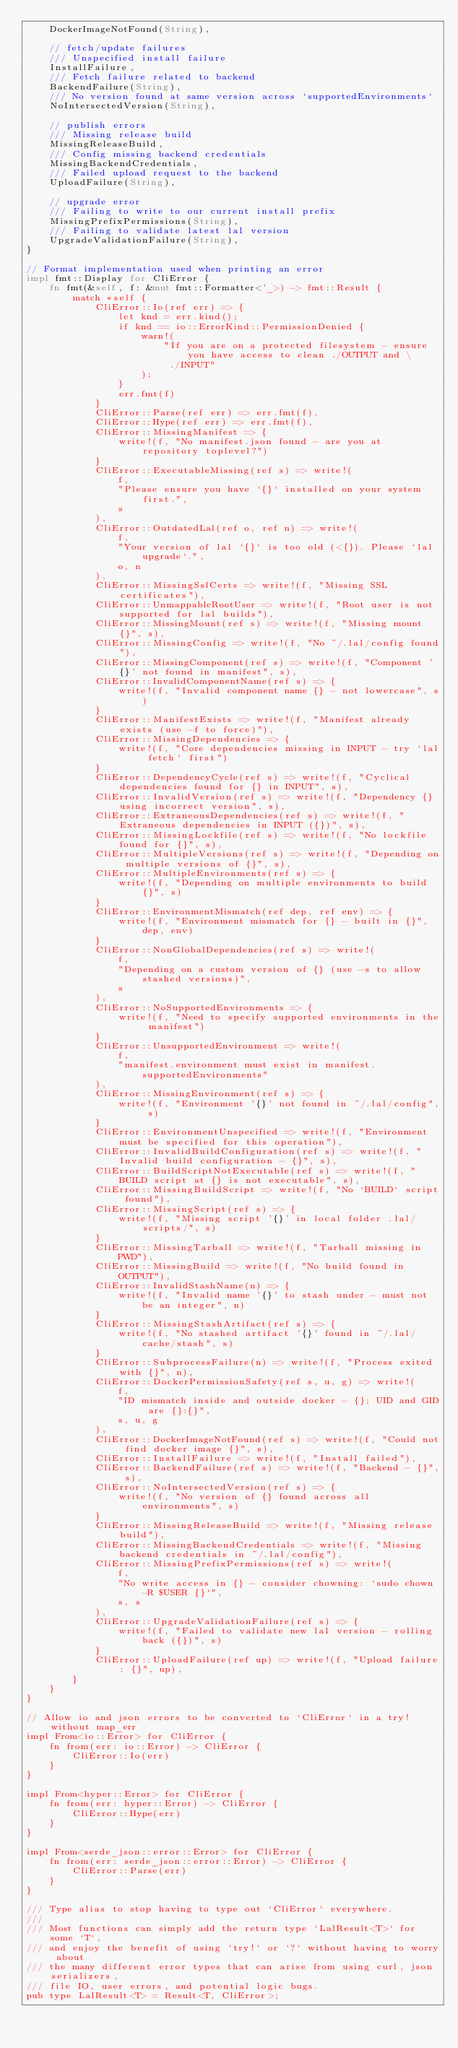Convert code to text. <code><loc_0><loc_0><loc_500><loc_500><_Rust_>    DockerImageNotFound(String),

    // fetch/update failures
    /// Unspecified install failure
    InstallFailure,
    /// Fetch failure related to backend
    BackendFailure(String),
    /// No version found at same version across `supportedEnvironments`
    NoIntersectedVersion(String),

    // publish errors
    /// Missing release build
    MissingReleaseBuild,
    /// Config missing backend credentials
    MissingBackendCredentials,
    /// Failed upload request to the backend
    UploadFailure(String),

    // upgrade error
    /// Failing to write to our current install prefix
    MissingPrefixPermissions(String),
    /// Failing to validate latest lal version
    UpgradeValidationFailure(String),
}

// Format implementation used when printing an error
impl fmt::Display for CliError {
    fn fmt(&self, f: &mut fmt::Formatter<'_>) -> fmt::Result {
        match *self {
            CliError::Io(ref err) => {
                let knd = err.kind();
                if knd == io::ErrorKind::PermissionDenied {
                    warn!(
                        "If you are on a protected filesystem - ensure you have access to clean ./OUTPUT and \
                         ./INPUT"
                    );
                }
                err.fmt(f)
            }
            CliError::Parse(ref err) => err.fmt(f),
            CliError::Hype(ref err) => err.fmt(f),
            CliError::MissingManifest => {
                write!(f, "No manifest.json found - are you at repository toplevel?")
            }
            CliError::ExecutableMissing(ref s) => write!(
                f,
                "Please ensure you have `{}` installed on your system first.",
                s
            ),
            CliError::OutdatedLal(ref o, ref n) => write!(
                f,
                "Your version of lal `{}` is too old (<{}). Please `lal upgrade`.",
                o, n
            ),
            CliError::MissingSslCerts => write!(f, "Missing SSL certificates"),
            CliError::UnmappableRootUser => write!(f, "Root user is not supported for lal builds"),
            CliError::MissingMount(ref s) => write!(f, "Missing mount {}", s),
            CliError::MissingConfig => write!(f, "No ~/.lal/config found"),
            CliError::MissingComponent(ref s) => write!(f, "Component '{}' not found in manifest", s),
            CliError::InvalidComponentName(ref s) => {
                write!(f, "Invalid component name {} - not lowercase", s)
            }
            CliError::ManifestExists => write!(f, "Manifest already exists (use -f to force)"),
            CliError::MissingDependencies => {
                write!(f, "Core dependencies missing in INPUT - try `lal fetch` first")
            }
            CliError::DependencyCycle(ref s) => write!(f, "Cyclical dependencies found for {} in INPUT", s),
            CliError::InvalidVersion(ref s) => write!(f, "Dependency {} using incorrect version", s),
            CliError::ExtraneousDependencies(ref s) => write!(f, "Extraneous dependencies in INPUT ({})", s),
            CliError::MissingLockfile(ref s) => write!(f, "No lockfile found for {}", s),
            CliError::MultipleVersions(ref s) => write!(f, "Depending on multiple versions of {}", s),
            CliError::MultipleEnvironments(ref s) => {
                write!(f, "Depending on multiple environments to build {}", s)
            }
            CliError::EnvironmentMismatch(ref dep, ref env) => {
                write!(f, "Environment mismatch for {} - built in {}", dep, env)
            }
            CliError::NonGlobalDependencies(ref s) => write!(
                f,
                "Depending on a custom version of {} (use -s to allow stashed versions)",
                s
            ),
            CliError::NoSupportedEnvironments => {
                write!(f, "Need to specify supported environments in the manifest")
            }
            CliError::UnsupportedEnvironment => write!(
                f,
                "manifest.environment must exist in manifest.supportedEnvironments"
            ),
            CliError::MissingEnvironment(ref s) => {
                write!(f, "Environment '{}' not found in ~/.lal/config", s)
            }
            CliError::EnvironmentUnspecified => write!(f, "Environment must be specified for this operation"),
            CliError::InvalidBuildConfiguration(ref s) => write!(f, "Invalid build configuration - {}", s),
            CliError::BuildScriptNotExecutable(ref s) => write!(f, "BUILD script at {} is not executable", s),
            CliError::MissingBuildScript => write!(f, "No `BUILD` script found"),
            CliError::MissingScript(ref s) => {
                write!(f, "Missing script '{}' in local folder .lal/scripts/", s)
            }
            CliError::MissingTarball => write!(f, "Tarball missing in PWD"),
            CliError::MissingBuild => write!(f, "No build found in OUTPUT"),
            CliError::InvalidStashName(n) => {
                write!(f, "Invalid name '{}' to stash under - must not be an integer", n)
            }
            CliError::MissingStashArtifact(ref s) => {
                write!(f, "No stashed artifact '{}' found in ~/.lal/cache/stash", s)
            }
            CliError::SubprocessFailure(n) => write!(f, "Process exited with {}", n),
            CliError::DockerPermissionSafety(ref s, u, g) => write!(
                f,
                "ID mismatch inside and outside docker - {}; UID and GID are {}:{}",
                s, u, g
            ),
            CliError::DockerImageNotFound(ref s) => write!(f, "Could not find docker image {}", s),
            CliError::InstallFailure => write!(f, "Install failed"),
            CliError::BackendFailure(ref s) => write!(f, "Backend - {}", s),
            CliError::NoIntersectedVersion(ref s) => {
                write!(f, "No version of {} found across all environments", s)
            }
            CliError::MissingReleaseBuild => write!(f, "Missing release build"),
            CliError::MissingBackendCredentials => write!(f, "Missing backend credentials in ~/.lal/config"),
            CliError::MissingPrefixPermissions(ref s) => write!(
                f,
                "No write access in {} - consider chowning: `sudo chown -R $USER {}`",
                s, s
            ),
            CliError::UpgradeValidationFailure(ref s) => {
                write!(f, "Failed to validate new lal version - rolling back ({})", s)
            }
            CliError::UploadFailure(ref up) => write!(f, "Upload failure: {}", up),
        }
    }
}

// Allow io and json errors to be converted to `CliError` in a try! without map_err
impl From<io::Error> for CliError {
    fn from(err: io::Error) -> CliError {
        CliError::Io(err)
    }
}

impl From<hyper::Error> for CliError {
    fn from(err: hyper::Error) -> CliError {
        CliError::Hype(err)
    }
}

impl From<serde_json::error::Error> for CliError {
    fn from(err: serde_json::error::Error) -> CliError {
        CliError::Parse(err)
    }
}

/// Type alias to stop having to type out `CliError` everywhere.
///
/// Most functions can simply add the return type `LalResult<T>` for some `T`,
/// and enjoy the benefit of using `try!` or `?` without having to worry about
/// the many different error types that can arise from using curl, json serializers,
/// file IO, user errors, and potential logic bugs.
pub type LalResult<T> = Result<T, CliError>;
</code> 